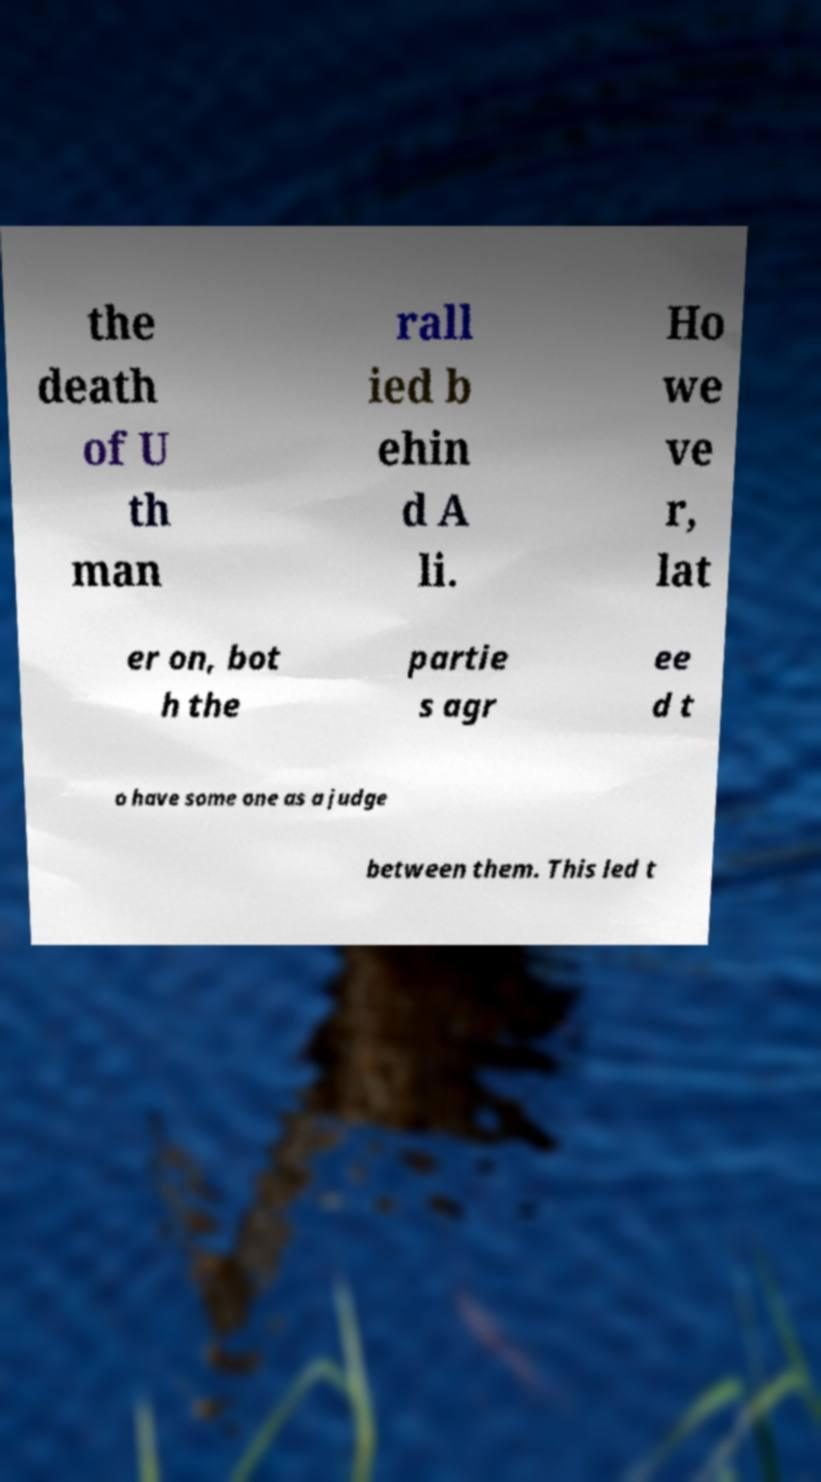Could you assist in decoding the text presented in this image and type it out clearly? the death of U th man rall ied b ehin d A li. Ho we ve r, lat er on, bot h the partie s agr ee d t o have some one as a judge between them. This led t 